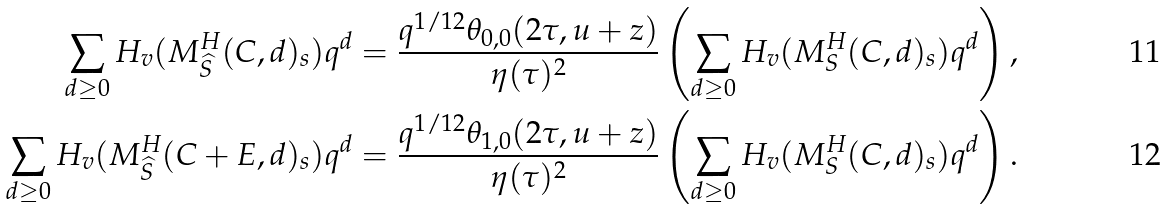<formula> <loc_0><loc_0><loc_500><loc_500>\sum _ { d \geq 0 } H _ { v } ( M ^ { H } _ { \widehat { S } } ( C , d ) _ { s } ) q ^ { d } & = \frac { q ^ { 1 / 1 2 } \theta _ { 0 , 0 } ( 2 \tau , u + z ) } { \eta ( \tau ) ^ { 2 } } \left ( \sum _ { d \geq 0 } H _ { v } ( M ^ { H } _ { S } ( C , d ) _ { s } ) q ^ { d } \right ) , \\ \sum _ { d \geq 0 } H _ { v } ( M ^ { H } _ { \widehat { S } } ( C + E , d ) _ { s } ) q ^ { d } & = \frac { q ^ { 1 / 1 2 } \theta _ { 1 , 0 } ( 2 \tau , u + z ) } { \eta ( \tau ) ^ { 2 } } \left ( \sum _ { d \geq 0 } H _ { v } ( M ^ { H } _ { S } ( C , d ) _ { s } ) q ^ { d } \right ) .</formula> 